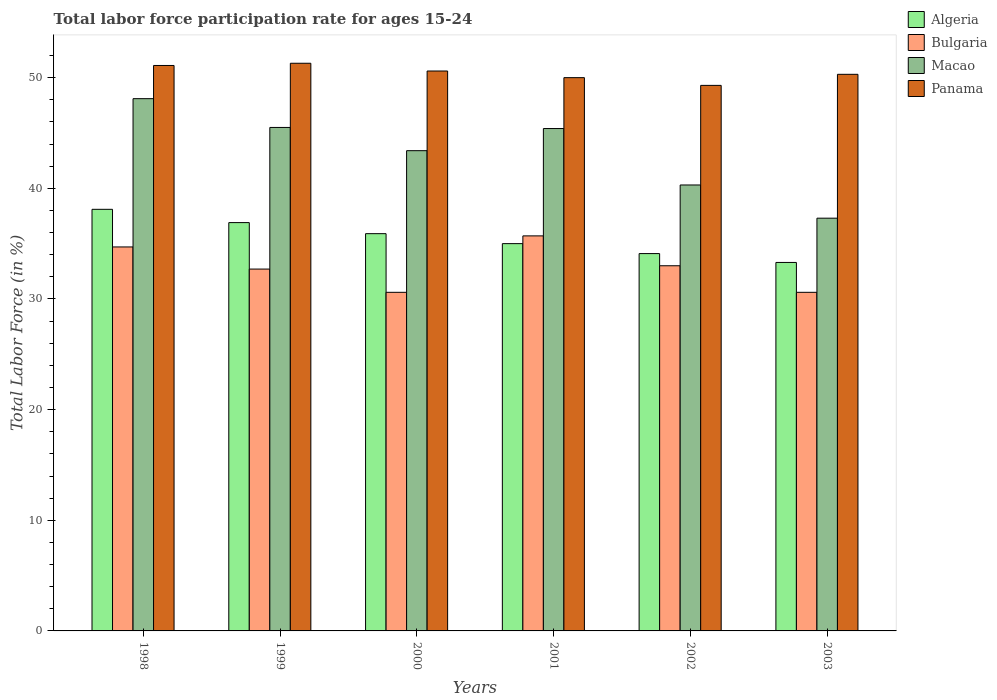How many different coloured bars are there?
Offer a terse response. 4. How many bars are there on the 5th tick from the left?
Your response must be concise. 4. How many bars are there on the 3rd tick from the right?
Offer a terse response. 4. What is the label of the 5th group of bars from the left?
Offer a very short reply. 2002. What is the labor force participation rate in Bulgaria in 2001?
Offer a very short reply. 35.7. Across all years, what is the maximum labor force participation rate in Algeria?
Offer a terse response. 38.1. Across all years, what is the minimum labor force participation rate in Algeria?
Give a very brief answer. 33.3. In which year was the labor force participation rate in Bulgaria maximum?
Keep it short and to the point. 2001. What is the total labor force participation rate in Macao in the graph?
Offer a terse response. 260. What is the difference between the labor force participation rate in Panama in 1998 and that in 1999?
Your response must be concise. -0.2. What is the difference between the labor force participation rate in Bulgaria in 1998 and the labor force participation rate in Panama in 1999?
Offer a terse response. -16.6. What is the average labor force participation rate in Algeria per year?
Ensure brevity in your answer.  35.55. In the year 1999, what is the difference between the labor force participation rate in Bulgaria and labor force participation rate in Algeria?
Provide a short and direct response. -4.2. In how many years, is the labor force participation rate in Bulgaria greater than 4 %?
Keep it short and to the point. 6. What is the ratio of the labor force participation rate in Algeria in 1999 to that in 2003?
Ensure brevity in your answer.  1.11. Is the labor force participation rate in Algeria in 1999 less than that in 2002?
Keep it short and to the point. No. Is the sum of the labor force participation rate in Panama in 1999 and 2000 greater than the maximum labor force participation rate in Bulgaria across all years?
Keep it short and to the point. Yes. Is it the case that in every year, the sum of the labor force participation rate in Macao and labor force participation rate in Algeria is greater than the sum of labor force participation rate in Bulgaria and labor force participation rate in Panama?
Provide a short and direct response. Yes. What does the 3rd bar from the left in 2001 represents?
Keep it short and to the point. Macao. What does the 4th bar from the right in 1998 represents?
Ensure brevity in your answer.  Algeria. Are all the bars in the graph horizontal?
Your answer should be compact. No. What is the difference between two consecutive major ticks on the Y-axis?
Keep it short and to the point. 10. How are the legend labels stacked?
Give a very brief answer. Vertical. What is the title of the graph?
Keep it short and to the point. Total labor force participation rate for ages 15-24. Does "Seychelles" appear as one of the legend labels in the graph?
Keep it short and to the point. No. What is the Total Labor Force (in %) of Algeria in 1998?
Your response must be concise. 38.1. What is the Total Labor Force (in %) of Bulgaria in 1998?
Your answer should be compact. 34.7. What is the Total Labor Force (in %) of Macao in 1998?
Provide a short and direct response. 48.1. What is the Total Labor Force (in %) in Panama in 1998?
Keep it short and to the point. 51.1. What is the Total Labor Force (in %) in Algeria in 1999?
Provide a short and direct response. 36.9. What is the Total Labor Force (in %) of Bulgaria in 1999?
Offer a very short reply. 32.7. What is the Total Labor Force (in %) of Macao in 1999?
Your answer should be compact. 45.5. What is the Total Labor Force (in %) in Panama in 1999?
Your answer should be very brief. 51.3. What is the Total Labor Force (in %) in Algeria in 2000?
Make the answer very short. 35.9. What is the Total Labor Force (in %) in Bulgaria in 2000?
Offer a terse response. 30.6. What is the Total Labor Force (in %) of Macao in 2000?
Keep it short and to the point. 43.4. What is the Total Labor Force (in %) of Panama in 2000?
Your answer should be very brief. 50.6. What is the Total Labor Force (in %) of Bulgaria in 2001?
Your answer should be very brief. 35.7. What is the Total Labor Force (in %) in Macao in 2001?
Provide a succinct answer. 45.4. What is the Total Labor Force (in %) in Algeria in 2002?
Provide a succinct answer. 34.1. What is the Total Labor Force (in %) of Macao in 2002?
Your answer should be very brief. 40.3. What is the Total Labor Force (in %) in Panama in 2002?
Offer a terse response. 49.3. What is the Total Labor Force (in %) in Algeria in 2003?
Offer a terse response. 33.3. What is the Total Labor Force (in %) in Bulgaria in 2003?
Offer a very short reply. 30.6. What is the Total Labor Force (in %) of Macao in 2003?
Keep it short and to the point. 37.3. What is the Total Labor Force (in %) in Panama in 2003?
Provide a succinct answer. 50.3. Across all years, what is the maximum Total Labor Force (in %) in Algeria?
Your response must be concise. 38.1. Across all years, what is the maximum Total Labor Force (in %) of Bulgaria?
Make the answer very short. 35.7. Across all years, what is the maximum Total Labor Force (in %) of Macao?
Offer a terse response. 48.1. Across all years, what is the maximum Total Labor Force (in %) of Panama?
Provide a succinct answer. 51.3. Across all years, what is the minimum Total Labor Force (in %) in Algeria?
Offer a terse response. 33.3. Across all years, what is the minimum Total Labor Force (in %) of Bulgaria?
Provide a succinct answer. 30.6. Across all years, what is the minimum Total Labor Force (in %) in Macao?
Give a very brief answer. 37.3. Across all years, what is the minimum Total Labor Force (in %) in Panama?
Your answer should be very brief. 49.3. What is the total Total Labor Force (in %) in Algeria in the graph?
Provide a short and direct response. 213.3. What is the total Total Labor Force (in %) of Bulgaria in the graph?
Your answer should be very brief. 197.3. What is the total Total Labor Force (in %) of Macao in the graph?
Offer a very short reply. 260. What is the total Total Labor Force (in %) in Panama in the graph?
Make the answer very short. 302.6. What is the difference between the Total Labor Force (in %) of Bulgaria in 1998 and that in 1999?
Ensure brevity in your answer.  2. What is the difference between the Total Labor Force (in %) of Macao in 1998 and that in 1999?
Offer a terse response. 2.6. What is the difference between the Total Labor Force (in %) in Bulgaria in 1998 and that in 2000?
Your answer should be very brief. 4.1. What is the difference between the Total Labor Force (in %) of Panama in 1998 and that in 2000?
Your answer should be compact. 0.5. What is the difference between the Total Labor Force (in %) of Bulgaria in 1998 and that in 2001?
Your response must be concise. -1. What is the difference between the Total Labor Force (in %) in Algeria in 1998 and that in 2002?
Keep it short and to the point. 4. What is the difference between the Total Labor Force (in %) in Bulgaria in 1998 and that in 2002?
Keep it short and to the point. 1.7. What is the difference between the Total Labor Force (in %) of Algeria in 1998 and that in 2003?
Make the answer very short. 4.8. What is the difference between the Total Labor Force (in %) in Panama in 1998 and that in 2003?
Offer a terse response. 0.8. What is the difference between the Total Labor Force (in %) in Bulgaria in 1999 and that in 2000?
Provide a succinct answer. 2.1. What is the difference between the Total Labor Force (in %) of Macao in 1999 and that in 2000?
Your response must be concise. 2.1. What is the difference between the Total Labor Force (in %) in Bulgaria in 1999 and that in 2001?
Your response must be concise. -3. What is the difference between the Total Labor Force (in %) in Macao in 1999 and that in 2001?
Offer a terse response. 0.1. What is the difference between the Total Labor Force (in %) in Algeria in 1999 and that in 2002?
Give a very brief answer. 2.8. What is the difference between the Total Labor Force (in %) of Macao in 1999 and that in 2002?
Ensure brevity in your answer.  5.2. What is the difference between the Total Labor Force (in %) of Panama in 1999 and that in 2003?
Ensure brevity in your answer.  1. What is the difference between the Total Labor Force (in %) in Panama in 2000 and that in 2001?
Make the answer very short. 0.6. What is the difference between the Total Labor Force (in %) of Macao in 2000 and that in 2002?
Make the answer very short. 3.1. What is the difference between the Total Labor Force (in %) in Algeria in 2000 and that in 2003?
Provide a short and direct response. 2.6. What is the difference between the Total Labor Force (in %) in Algeria in 2001 and that in 2002?
Your answer should be very brief. 0.9. What is the difference between the Total Labor Force (in %) in Macao in 2001 and that in 2003?
Provide a succinct answer. 8.1. What is the difference between the Total Labor Force (in %) of Panama in 2001 and that in 2003?
Ensure brevity in your answer.  -0.3. What is the difference between the Total Labor Force (in %) in Algeria in 2002 and that in 2003?
Make the answer very short. 0.8. What is the difference between the Total Labor Force (in %) in Bulgaria in 2002 and that in 2003?
Your answer should be very brief. 2.4. What is the difference between the Total Labor Force (in %) in Panama in 2002 and that in 2003?
Your response must be concise. -1. What is the difference between the Total Labor Force (in %) in Bulgaria in 1998 and the Total Labor Force (in %) in Macao in 1999?
Ensure brevity in your answer.  -10.8. What is the difference between the Total Labor Force (in %) of Bulgaria in 1998 and the Total Labor Force (in %) of Panama in 1999?
Make the answer very short. -16.6. What is the difference between the Total Labor Force (in %) in Algeria in 1998 and the Total Labor Force (in %) in Panama in 2000?
Offer a very short reply. -12.5. What is the difference between the Total Labor Force (in %) of Bulgaria in 1998 and the Total Labor Force (in %) of Panama in 2000?
Your answer should be compact. -15.9. What is the difference between the Total Labor Force (in %) in Algeria in 1998 and the Total Labor Force (in %) in Bulgaria in 2001?
Give a very brief answer. 2.4. What is the difference between the Total Labor Force (in %) in Algeria in 1998 and the Total Labor Force (in %) in Panama in 2001?
Your answer should be very brief. -11.9. What is the difference between the Total Labor Force (in %) of Bulgaria in 1998 and the Total Labor Force (in %) of Macao in 2001?
Your answer should be very brief. -10.7. What is the difference between the Total Labor Force (in %) of Bulgaria in 1998 and the Total Labor Force (in %) of Panama in 2001?
Your answer should be very brief. -15.3. What is the difference between the Total Labor Force (in %) of Algeria in 1998 and the Total Labor Force (in %) of Panama in 2002?
Your response must be concise. -11.2. What is the difference between the Total Labor Force (in %) in Bulgaria in 1998 and the Total Labor Force (in %) in Macao in 2002?
Ensure brevity in your answer.  -5.6. What is the difference between the Total Labor Force (in %) of Bulgaria in 1998 and the Total Labor Force (in %) of Panama in 2002?
Ensure brevity in your answer.  -14.6. What is the difference between the Total Labor Force (in %) in Bulgaria in 1998 and the Total Labor Force (in %) in Macao in 2003?
Your response must be concise. -2.6. What is the difference between the Total Labor Force (in %) of Bulgaria in 1998 and the Total Labor Force (in %) of Panama in 2003?
Your response must be concise. -15.6. What is the difference between the Total Labor Force (in %) in Macao in 1998 and the Total Labor Force (in %) in Panama in 2003?
Provide a succinct answer. -2.2. What is the difference between the Total Labor Force (in %) in Algeria in 1999 and the Total Labor Force (in %) in Panama in 2000?
Your answer should be very brief. -13.7. What is the difference between the Total Labor Force (in %) in Bulgaria in 1999 and the Total Labor Force (in %) in Macao in 2000?
Offer a terse response. -10.7. What is the difference between the Total Labor Force (in %) in Bulgaria in 1999 and the Total Labor Force (in %) in Panama in 2000?
Your answer should be very brief. -17.9. What is the difference between the Total Labor Force (in %) of Macao in 1999 and the Total Labor Force (in %) of Panama in 2000?
Provide a short and direct response. -5.1. What is the difference between the Total Labor Force (in %) of Algeria in 1999 and the Total Labor Force (in %) of Macao in 2001?
Your answer should be compact. -8.5. What is the difference between the Total Labor Force (in %) in Bulgaria in 1999 and the Total Labor Force (in %) in Macao in 2001?
Your response must be concise. -12.7. What is the difference between the Total Labor Force (in %) in Bulgaria in 1999 and the Total Labor Force (in %) in Panama in 2001?
Offer a very short reply. -17.3. What is the difference between the Total Labor Force (in %) of Algeria in 1999 and the Total Labor Force (in %) of Macao in 2002?
Your answer should be very brief. -3.4. What is the difference between the Total Labor Force (in %) in Algeria in 1999 and the Total Labor Force (in %) in Panama in 2002?
Make the answer very short. -12.4. What is the difference between the Total Labor Force (in %) in Bulgaria in 1999 and the Total Labor Force (in %) in Panama in 2002?
Offer a very short reply. -16.6. What is the difference between the Total Labor Force (in %) in Algeria in 1999 and the Total Labor Force (in %) in Macao in 2003?
Keep it short and to the point. -0.4. What is the difference between the Total Labor Force (in %) of Algeria in 1999 and the Total Labor Force (in %) of Panama in 2003?
Make the answer very short. -13.4. What is the difference between the Total Labor Force (in %) of Bulgaria in 1999 and the Total Labor Force (in %) of Macao in 2003?
Make the answer very short. -4.6. What is the difference between the Total Labor Force (in %) of Bulgaria in 1999 and the Total Labor Force (in %) of Panama in 2003?
Offer a terse response. -17.6. What is the difference between the Total Labor Force (in %) of Algeria in 2000 and the Total Labor Force (in %) of Bulgaria in 2001?
Ensure brevity in your answer.  0.2. What is the difference between the Total Labor Force (in %) of Algeria in 2000 and the Total Labor Force (in %) of Macao in 2001?
Provide a succinct answer. -9.5. What is the difference between the Total Labor Force (in %) of Algeria in 2000 and the Total Labor Force (in %) of Panama in 2001?
Ensure brevity in your answer.  -14.1. What is the difference between the Total Labor Force (in %) in Bulgaria in 2000 and the Total Labor Force (in %) in Macao in 2001?
Your answer should be very brief. -14.8. What is the difference between the Total Labor Force (in %) in Bulgaria in 2000 and the Total Labor Force (in %) in Panama in 2001?
Keep it short and to the point. -19.4. What is the difference between the Total Labor Force (in %) in Algeria in 2000 and the Total Labor Force (in %) in Bulgaria in 2002?
Provide a short and direct response. 2.9. What is the difference between the Total Labor Force (in %) in Algeria in 2000 and the Total Labor Force (in %) in Macao in 2002?
Make the answer very short. -4.4. What is the difference between the Total Labor Force (in %) in Bulgaria in 2000 and the Total Labor Force (in %) in Macao in 2002?
Ensure brevity in your answer.  -9.7. What is the difference between the Total Labor Force (in %) of Bulgaria in 2000 and the Total Labor Force (in %) of Panama in 2002?
Give a very brief answer. -18.7. What is the difference between the Total Labor Force (in %) of Macao in 2000 and the Total Labor Force (in %) of Panama in 2002?
Offer a terse response. -5.9. What is the difference between the Total Labor Force (in %) of Algeria in 2000 and the Total Labor Force (in %) of Bulgaria in 2003?
Your response must be concise. 5.3. What is the difference between the Total Labor Force (in %) in Algeria in 2000 and the Total Labor Force (in %) in Panama in 2003?
Offer a terse response. -14.4. What is the difference between the Total Labor Force (in %) in Bulgaria in 2000 and the Total Labor Force (in %) in Macao in 2003?
Keep it short and to the point. -6.7. What is the difference between the Total Labor Force (in %) of Bulgaria in 2000 and the Total Labor Force (in %) of Panama in 2003?
Offer a very short reply. -19.7. What is the difference between the Total Labor Force (in %) in Algeria in 2001 and the Total Labor Force (in %) in Bulgaria in 2002?
Your answer should be compact. 2. What is the difference between the Total Labor Force (in %) of Algeria in 2001 and the Total Labor Force (in %) of Panama in 2002?
Offer a terse response. -14.3. What is the difference between the Total Labor Force (in %) in Macao in 2001 and the Total Labor Force (in %) in Panama in 2002?
Your response must be concise. -3.9. What is the difference between the Total Labor Force (in %) in Algeria in 2001 and the Total Labor Force (in %) in Bulgaria in 2003?
Provide a short and direct response. 4.4. What is the difference between the Total Labor Force (in %) in Algeria in 2001 and the Total Labor Force (in %) in Macao in 2003?
Offer a very short reply. -2.3. What is the difference between the Total Labor Force (in %) of Algeria in 2001 and the Total Labor Force (in %) of Panama in 2003?
Ensure brevity in your answer.  -15.3. What is the difference between the Total Labor Force (in %) of Bulgaria in 2001 and the Total Labor Force (in %) of Macao in 2003?
Offer a terse response. -1.6. What is the difference between the Total Labor Force (in %) in Bulgaria in 2001 and the Total Labor Force (in %) in Panama in 2003?
Ensure brevity in your answer.  -14.6. What is the difference between the Total Labor Force (in %) of Algeria in 2002 and the Total Labor Force (in %) of Bulgaria in 2003?
Give a very brief answer. 3.5. What is the difference between the Total Labor Force (in %) in Algeria in 2002 and the Total Labor Force (in %) in Macao in 2003?
Provide a succinct answer. -3.2. What is the difference between the Total Labor Force (in %) of Algeria in 2002 and the Total Labor Force (in %) of Panama in 2003?
Offer a very short reply. -16.2. What is the difference between the Total Labor Force (in %) of Bulgaria in 2002 and the Total Labor Force (in %) of Macao in 2003?
Keep it short and to the point. -4.3. What is the difference between the Total Labor Force (in %) of Bulgaria in 2002 and the Total Labor Force (in %) of Panama in 2003?
Ensure brevity in your answer.  -17.3. What is the difference between the Total Labor Force (in %) of Macao in 2002 and the Total Labor Force (in %) of Panama in 2003?
Your response must be concise. -10. What is the average Total Labor Force (in %) in Algeria per year?
Offer a very short reply. 35.55. What is the average Total Labor Force (in %) in Bulgaria per year?
Offer a terse response. 32.88. What is the average Total Labor Force (in %) of Macao per year?
Provide a succinct answer. 43.33. What is the average Total Labor Force (in %) in Panama per year?
Your answer should be very brief. 50.43. In the year 1998, what is the difference between the Total Labor Force (in %) of Algeria and Total Labor Force (in %) of Bulgaria?
Offer a terse response. 3.4. In the year 1998, what is the difference between the Total Labor Force (in %) of Bulgaria and Total Labor Force (in %) of Panama?
Make the answer very short. -16.4. In the year 1999, what is the difference between the Total Labor Force (in %) of Algeria and Total Labor Force (in %) of Macao?
Provide a succinct answer. -8.6. In the year 1999, what is the difference between the Total Labor Force (in %) in Algeria and Total Labor Force (in %) in Panama?
Your answer should be compact. -14.4. In the year 1999, what is the difference between the Total Labor Force (in %) in Bulgaria and Total Labor Force (in %) in Panama?
Give a very brief answer. -18.6. In the year 1999, what is the difference between the Total Labor Force (in %) of Macao and Total Labor Force (in %) of Panama?
Your answer should be compact. -5.8. In the year 2000, what is the difference between the Total Labor Force (in %) in Algeria and Total Labor Force (in %) in Panama?
Provide a short and direct response. -14.7. In the year 2000, what is the difference between the Total Labor Force (in %) of Macao and Total Labor Force (in %) of Panama?
Ensure brevity in your answer.  -7.2. In the year 2001, what is the difference between the Total Labor Force (in %) of Bulgaria and Total Labor Force (in %) of Macao?
Make the answer very short. -9.7. In the year 2001, what is the difference between the Total Labor Force (in %) in Bulgaria and Total Labor Force (in %) in Panama?
Your response must be concise. -14.3. In the year 2001, what is the difference between the Total Labor Force (in %) of Macao and Total Labor Force (in %) of Panama?
Make the answer very short. -4.6. In the year 2002, what is the difference between the Total Labor Force (in %) of Algeria and Total Labor Force (in %) of Panama?
Offer a very short reply. -15.2. In the year 2002, what is the difference between the Total Labor Force (in %) of Bulgaria and Total Labor Force (in %) of Panama?
Your response must be concise. -16.3. In the year 2002, what is the difference between the Total Labor Force (in %) of Macao and Total Labor Force (in %) of Panama?
Your answer should be compact. -9. In the year 2003, what is the difference between the Total Labor Force (in %) in Algeria and Total Labor Force (in %) in Bulgaria?
Offer a terse response. 2.7. In the year 2003, what is the difference between the Total Labor Force (in %) of Algeria and Total Labor Force (in %) of Macao?
Your answer should be compact. -4. In the year 2003, what is the difference between the Total Labor Force (in %) of Bulgaria and Total Labor Force (in %) of Panama?
Keep it short and to the point. -19.7. What is the ratio of the Total Labor Force (in %) of Algeria in 1998 to that in 1999?
Your answer should be very brief. 1.03. What is the ratio of the Total Labor Force (in %) of Bulgaria in 1998 to that in 1999?
Make the answer very short. 1.06. What is the ratio of the Total Labor Force (in %) in Macao in 1998 to that in 1999?
Offer a very short reply. 1.06. What is the ratio of the Total Labor Force (in %) of Panama in 1998 to that in 1999?
Your answer should be very brief. 1. What is the ratio of the Total Labor Force (in %) of Algeria in 1998 to that in 2000?
Your answer should be very brief. 1.06. What is the ratio of the Total Labor Force (in %) in Bulgaria in 1998 to that in 2000?
Keep it short and to the point. 1.13. What is the ratio of the Total Labor Force (in %) of Macao in 1998 to that in 2000?
Give a very brief answer. 1.11. What is the ratio of the Total Labor Force (in %) in Panama in 1998 to that in 2000?
Offer a terse response. 1.01. What is the ratio of the Total Labor Force (in %) in Algeria in 1998 to that in 2001?
Your response must be concise. 1.09. What is the ratio of the Total Labor Force (in %) in Macao in 1998 to that in 2001?
Offer a very short reply. 1.06. What is the ratio of the Total Labor Force (in %) of Algeria in 1998 to that in 2002?
Keep it short and to the point. 1.12. What is the ratio of the Total Labor Force (in %) of Bulgaria in 1998 to that in 2002?
Ensure brevity in your answer.  1.05. What is the ratio of the Total Labor Force (in %) in Macao in 1998 to that in 2002?
Provide a succinct answer. 1.19. What is the ratio of the Total Labor Force (in %) in Panama in 1998 to that in 2002?
Give a very brief answer. 1.04. What is the ratio of the Total Labor Force (in %) in Algeria in 1998 to that in 2003?
Your answer should be compact. 1.14. What is the ratio of the Total Labor Force (in %) of Bulgaria in 1998 to that in 2003?
Offer a terse response. 1.13. What is the ratio of the Total Labor Force (in %) of Macao in 1998 to that in 2003?
Offer a very short reply. 1.29. What is the ratio of the Total Labor Force (in %) in Panama in 1998 to that in 2003?
Give a very brief answer. 1.02. What is the ratio of the Total Labor Force (in %) of Algeria in 1999 to that in 2000?
Ensure brevity in your answer.  1.03. What is the ratio of the Total Labor Force (in %) of Bulgaria in 1999 to that in 2000?
Your response must be concise. 1.07. What is the ratio of the Total Labor Force (in %) in Macao in 1999 to that in 2000?
Your answer should be compact. 1.05. What is the ratio of the Total Labor Force (in %) in Panama in 1999 to that in 2000?
Provide a succinct answer. 1.01. What is the ratio of the Total Labor Force (in %) of Algeria in 1999 to that in 2001?
Your answer should be compact. 1.05. What is the ratio of the Total Labor Force (in %) in Bulgaria in 1999 to that in 2001?
Ensure brevity in your answer.  0.92. What is the ratio of the Total Labor Force (in %) in Macao in 1999 to that in 2001?
Offer a very short reply. 1. What is the ratio of the Total Labor Force (in %) in Panama in 1999 to that in 2001?
Your answer should be very brief. 1.03. What is the ratio of the Total Labor Force (in %) of Algeria in 1999 to that in 2002?
Offer a terse response. 1.08. What is the ratio of the Total Labor Force (in %) in Bulgaria in 1999 to that in 2002?
Provide a succinct answer. 0.99. What is the ratio of the Total Labor Force (in %) of Macao in 1999 to that in 2002?
Give a very brief answer. 1.13. What is the ratio of the Total Labor Force (in %) in Panama in 1999 to that in 2002?
Offer a terse response. 1.04. What is the ratio of the Total Labor Force (in %) in Algeria in 1999 to that in 2003?
Offer a terse response. 1.11. What is the ratio of the Total Labor Force (in %) in Bulgaria in 1999 to that in 2003?
Your answer should be very brief. 1.07. What is the ratio of the Total Labor Force (in %) in Macao in 1999 to that in 2003?
Your answer should be very brief. 1.22. What is the ratio of the Total Labor Force (in %) in Panama in 1999 to that in 2003?
Your answer should be compact. 1.02. What is the ratio of the Total Labor Force (in %) of Algeria in 2000 to that in 2001?
Your answer should be very brief. 1.03. What is the ratio of the Total Labor Force (in %) in Bulgaria in 2000 to that in 2001?
Your answer should be very brief. 0.86. What is the ratio of the Total Labor Force (in %) of Macao in 2000 to that in 2001?
Your answer should be compact. 0.96. What is the ratio of the Total Labor Force (in %) in Algeria in 2000 to that in 2002?
Provide a short and direct response. 1.05. What is the ratio of the Total Labor Force (in %) of Bulgaria in 2000 to that in 2002?
Offer a very short reply. 0.93. What is the ratio of the Total Labor Force (in %) in Macao in 2000 to that in 2002?
Provide a succinct answer. 1.08. What is the ratio of the Total Labor Force (in %) in Panama in 2000 to that in 2002?
Provide a succinct answer. 1.03. What is the ratio of the Total Labor Force (in %) of Algeria in 2000 to that in 2003?
Provide a short and direct response. 1.08. What is the ratio of the Total Labor Force (in %) in Bulgaria in 2000 to that in 2003?
Keep it short and to the point. 1. What is the ratio of the Total Labor Force (in %) of Macao in 2000 to that in 2003?
Your response must be concise. 1.16. What is the ratio of the Total Labor Force (in %) in Panama in 2000 to that in 2003?
Provide a succinct answer. 1.01. What is the ratio of the Total Labor Force (in %) of Algeria in 2001 to that in 2002?
Your answer should be very brief. 1.03. What is the ratio of the Total Labor Force (in %) in Bulgaria in 2001 to that in 2002?
Your response must be concise. 1.08. What is the ratio of the Total Labor Force (in %) in Macao in 2001 to that in 2002?
Your answer should be compact. 1.13. What is the ratio of the Total Labor Force (in %) of Panama in 2001 to that in 2002?
Offer a very short reply. 1.01. What is the ratio of the Total Labor Force (in %) in Algeria in 2001 to that in 2003?
Your response must be concise. 1.05. What is the ratio of the Total Labor Force (in %) of Bulgaria in 2001 to that in 2003?
Give a very brief answer. 1.17. What is the ratio of the Total Labor Force (in %) in Macao in 2001 to that in 2003?
Keep it short and to the point. 1.22. What is the ratio of the Total Labor Force (in %) of Panama in 2001 to that in 2003?
Provide a succinct answer. 0.99. What is the ratio of the Total Labor Force (in %) of Algeria in 2002 to that in 2003?
Your answer should be very brief. 1.02. What is the ratio of the Total Labor Force (in %) in Bulgaria in 2002 to that in 2003?
Make the answer very short. 1.08. What is the ratio of the Total Labor Force (in %) in Macao in 2002 to that in 2003?
Offer a terse response. 1.08. What is the ratio of the Total Labor Force (in %) of Panama in 2002 to that in 2003?
Your answer should be compact. 0.98. What is the difference between the highest and the second highest Total Labor Force (in %) in Panama?
Make the answer very short. 0.2. What is the difference between the highest and the lowest Total Labor Force (in %) in Bulgaria?
Keep it short and to the point. 5.1. What is the difference between the highest and the lowest Total Labor Force (in %) of Macao?
Make the answer very short. 10.8. 